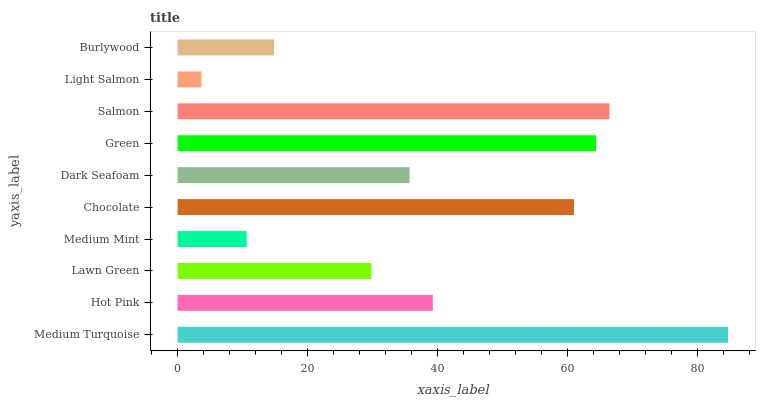Is Light Salmon the minimum?
Answer yes or no. Yes. Is Medium Turquoise the maximum?
Answer yes or no. Yes. Is Hot Pink the minimum?
Answer yes or no. No. Is Hot Pink the maximum?
Answer yes or no. No. Is Medium Turquoise greater than Hot Pink?
Answer yes or no. Yes. Is Hot Pink less than Medium Turquoise?
Answer yes or no. Yes. Is Hot Pink greater than Medium Turquoise?
Answer yes or no. No. Is Medium Turquoise less than Hot Pink?
Answer yes or no. No. Is Hot Pink the high median?
Answer yes or no. Yes. Is Dark Seafoam the low median?
Answer yes or no. Yes. Is Green the high median?
Answer yes or no. No. Is Burlywood the low median?
Answer yes or no. No. 